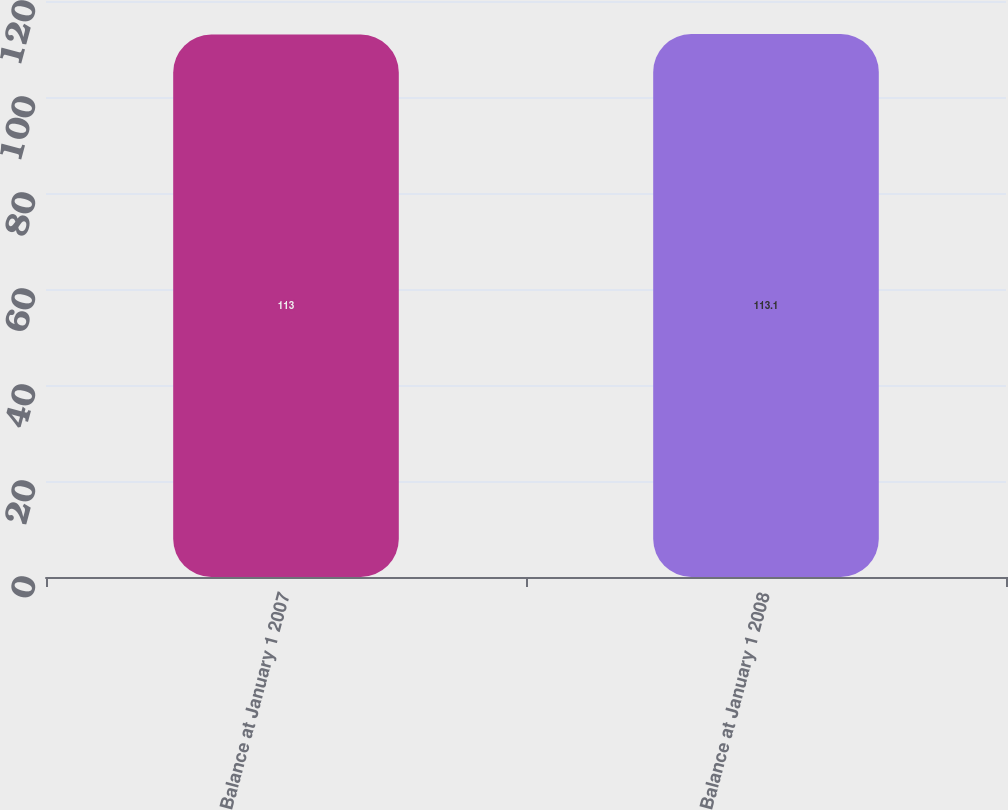<chart> <loc_0><loc_0><loc_500><loc_500><bar_chart><fcel>Balance at January 1 2007<fcel>Balance at January 1 2008<nl><fcel>113<fcel>113.1<nl></chart> 